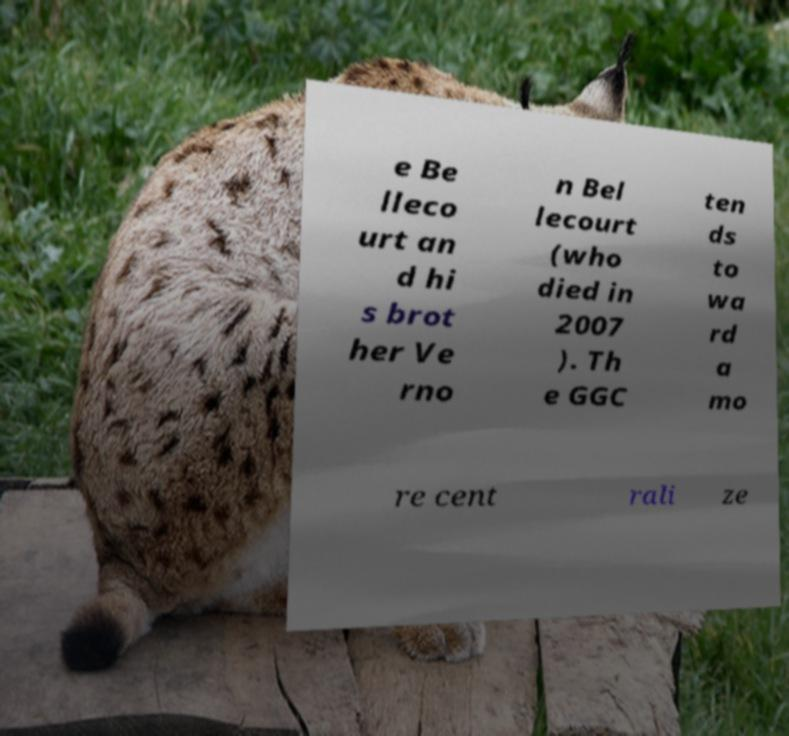Please identify and transcribe the text found in this image. e Be lleco urt an d hi s brot her Ve rno n Bel lecourt (who died in 2007 ). Th e GGC ten ds to wa rd a mo re cent rali ze 